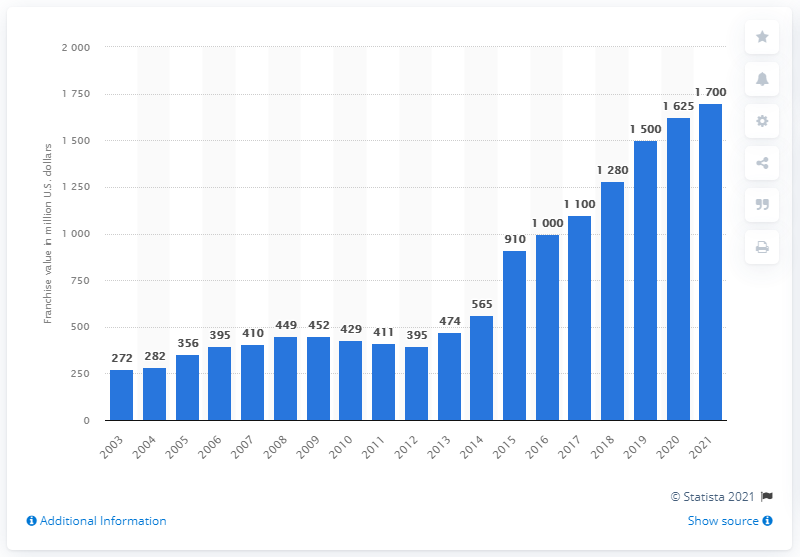Give some essential details in this illustration. The estimated value of the Phoenix Suns in 2021 was approximately 1,700. 